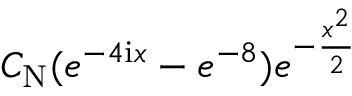<formula> <loc_0><loc_0><loc_500><loc_500>C _ { N } ( e ^ { - 4 i x } - e ^ { - 8 } ) e ^ { - \frac { x ^ { 2 } } { 2 } }</formula> 